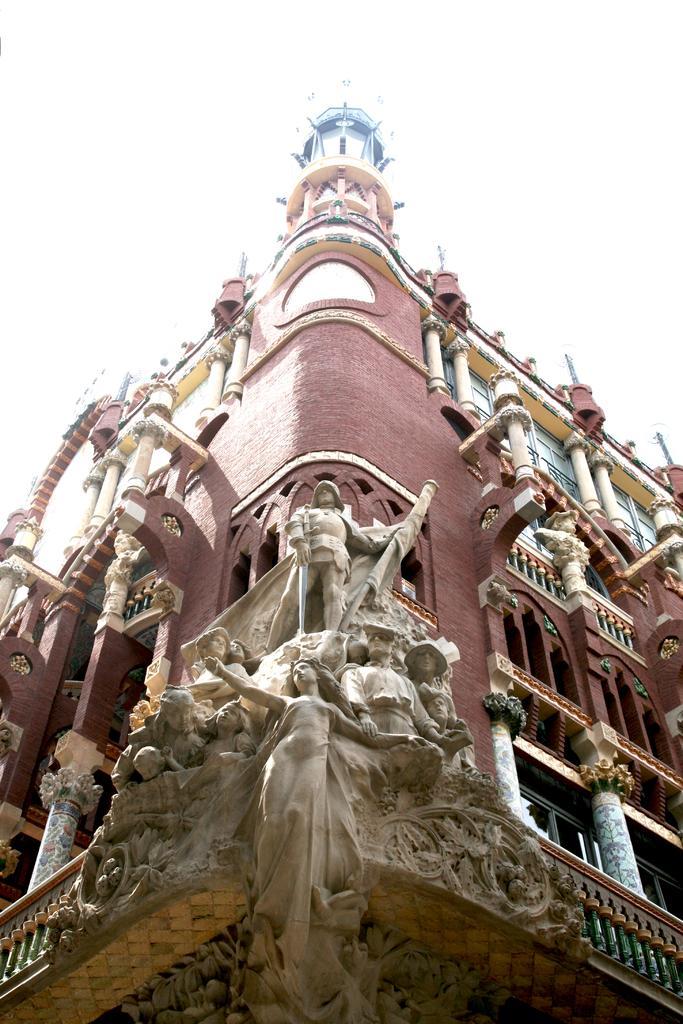Could you give a brief overview of what you see in this image? In this picture there is a building. On the building we can see windows, pillar, statues and concrete fencing. At the top there is a sky. 